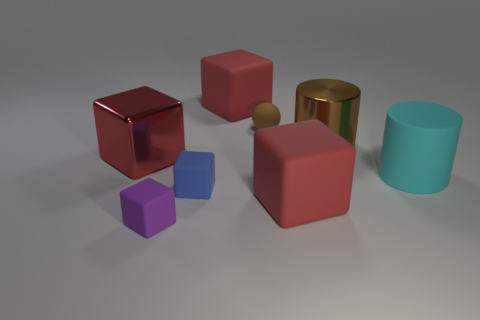There is a cylinder that is the same color as the matte sphere; what size is it?
Offer a very short reply. Large. There is a object that is behind the brown ball; what is its size?
Provide a succinct answer. Large. There is another shiny thing that is the same shape as the blue thing; what color is it?
Your answer should be compact. Red. How many tiny rubber blocks are the same color as the rubber sphere?
Provide a succinct answer. 0. Is there any other thing that has the same shape as the cyan object?
Give a very brief answer. Yes. Is there a large red cube to the right of the small brown ball that is to the right of the small matte thing to the left of the blue object?
Offer a very short reply. Yes. How many other things are made of the same material as the small brown object?
Offer a terse response. 5. Does the red matte block to the right of the brown sphere have the same size as the red rubber thing that is behind the brown sphere?
Offer a very short reply. Yes. What is the color of the thing that is on the left side of the purple matte thing in front of the big metallic object on the right side of the purple thing?
Provide a succinct answer. Red. Is there another small blue rubber thing that has the same shape as the blue thing?
Keep it short and to the point. No. 